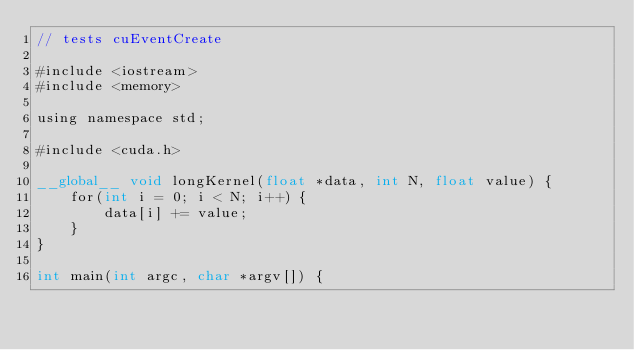<code> <loc_0><loc_0><loc_500><loc_500><_Cuda_>// tests cuEventCreate

#include <iostream>
#include <memory>

using namespace std;

#include <cuda.h>

__global__ void longKernel(float *data, int N, float value) {
    for(int i = 0; i < N; i++) {
        data[i] += value;
    }
}

int main(int argc, char *argv[]) {</code> 